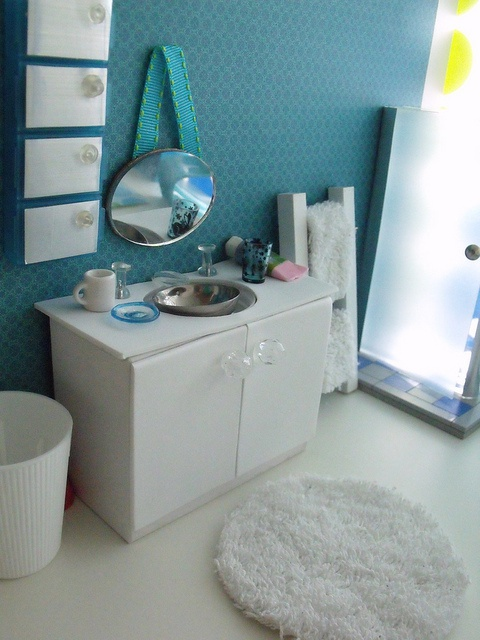Describe the objects in this image and their specific colors. I can see sink in black, gray, darkgray, and lightgray tones, bowl in black, gray, darkgray, and lightgray tones, cup in black, darkgray, and gray tones, and cup in black, teal, darkblue, and gray tones in this image. 